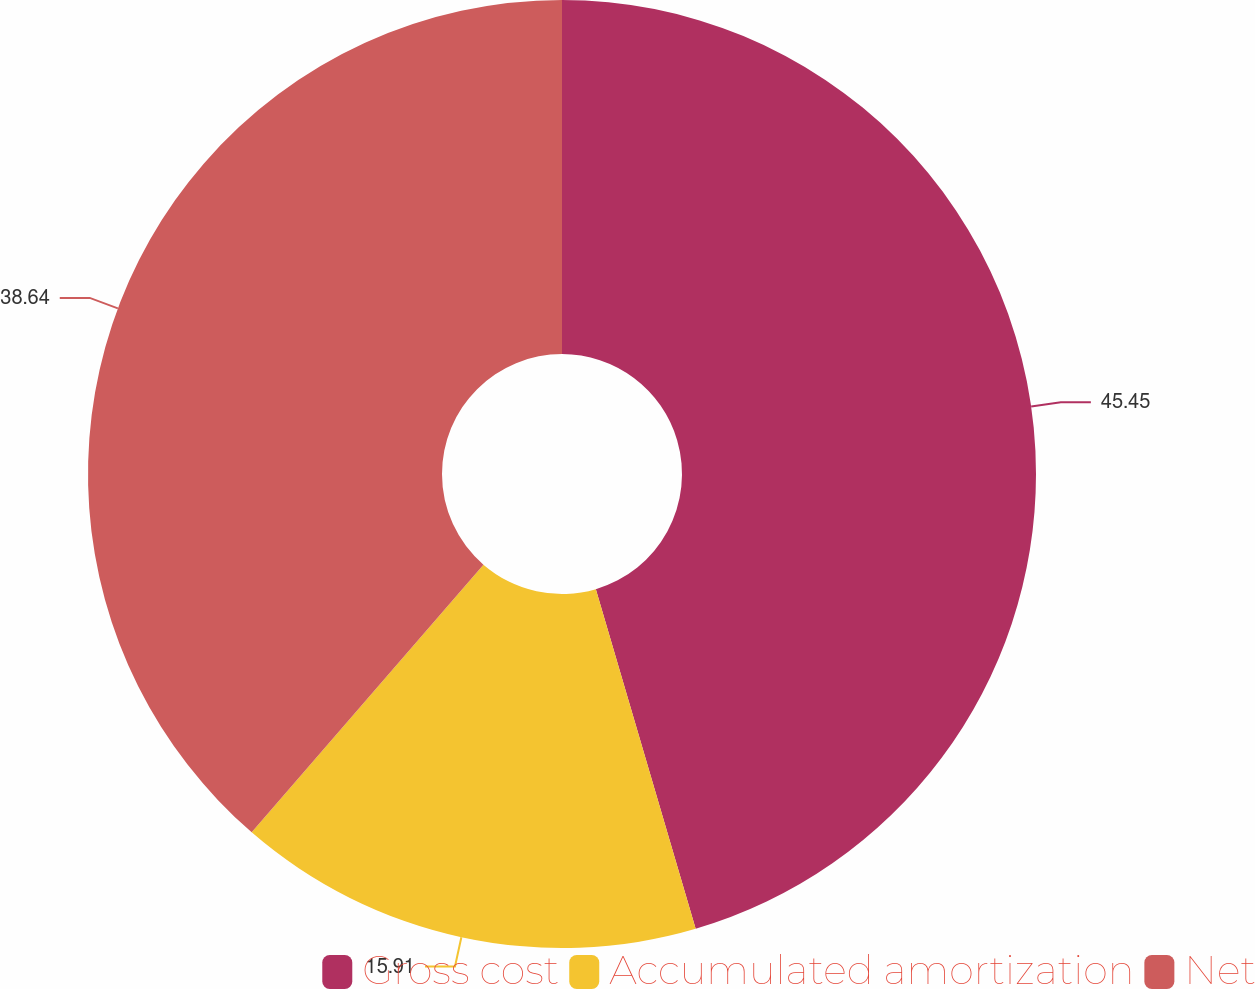<chart> <loc_0><loc_0><loc_500><loc_500><pie_chart><fcel>Gross cost<fcel>Accumulated amortization<fcel>Net<nl><fcel>45.45%<fcel>15.91%<fcel>38.64%<nl></chart> 